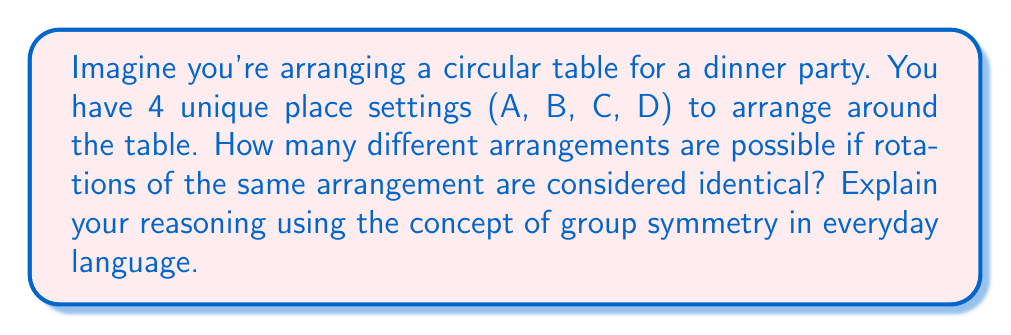Solve this math problem. Let's break this down step-by-step using everyday language:

1. First, let's understand what we mean by "rotations of the same arrangement are considered identical":
   - If we rotate the entire table, the arrangement looks the same to us.
   - This is like spinning a pizza - the toppings are in the same relative positions, just rotated.

2. Now, let's think about group symmetry:
   - In simple terms, group symmetry is about finding patterns that stay the same when we do certain actions (like rotating).
   - For our circular table, the "group" is all the ways we can rotate the table that make it look the same.

3. How many rotations make our table look the same?
   - With 4 place settings, we can rotate 0°, 90°, 180°, or 270°, and the table will look different each time.
   - But when we complete a full 360° rotation, we're back where we started.
   - So, our group has 4 elements (these 4 rotations).

4. Now, let's count the unique arrangements:
   - If there were no symmetry, we could arrange 4 items in $4! = 24$ ways.
   - But because of the rotational symmetry, each unique arrangement can be rotated 4 ways.
   - So, we need to divide the total number of arrangements by the number of rotations.

5. The mathematical formula for this is:
   $$\text{Unique arrangements} = \frac{\text{Total arrangements}}{\text{Number of symmetries}}$$

6. Plugging in our numbers:
   $$\text{Unique arrangements} = \frac{4!}{4} = \frac{24}{4} = 6$$

Therefore, there are 6 unique arrangements of the place settings around the circular table.
Answer: 6 unique arrangements 